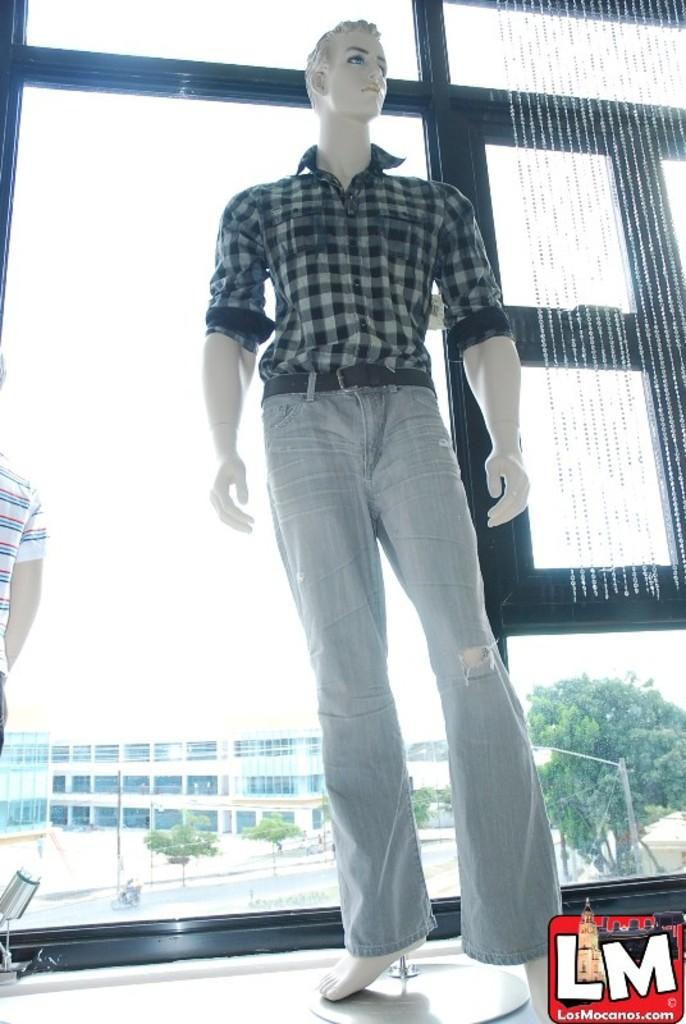What is the main subject in the image? There is a mannequin with a dress in the image. What can be seen in the background of the image? There is a building, trees, and a light pole in the background of the image. Are there any decorations visible in the image? Yes, decorative items are hanged on the window. What type of pan is being used to cook the rose in the image? There is no pan or rose present in the image. 